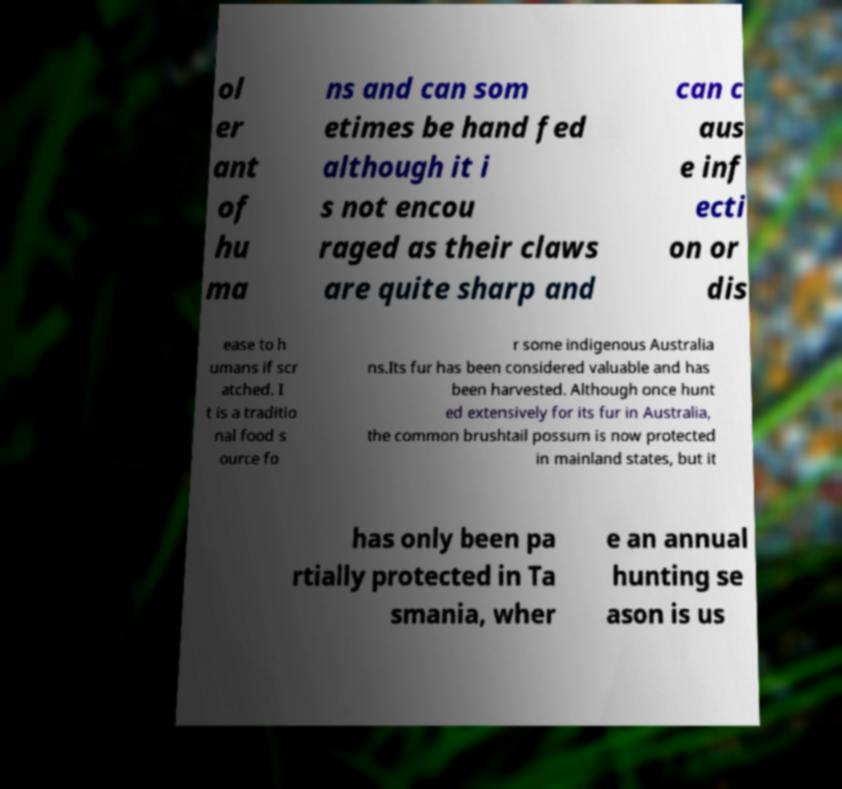Can you accurately transcribe the text from the provided image for me? ol er ant of hu ma ns and can som etimes be hand fed although it i s not encou raged as their claws are quite sharp and can c aus e inf ecti on or dis ease to h umans if scr atched. I t is a traditio nal food s ource fo r some indigenous Australia ns.Its fur has been considered valuable and has been harvested. Although once hunt ed extensively for its fur in Australia, the common brushtail possum is now protected in mainland states, but it has only been pa rtially protected in Ta smania, wher e an annual hunting se ason is us 